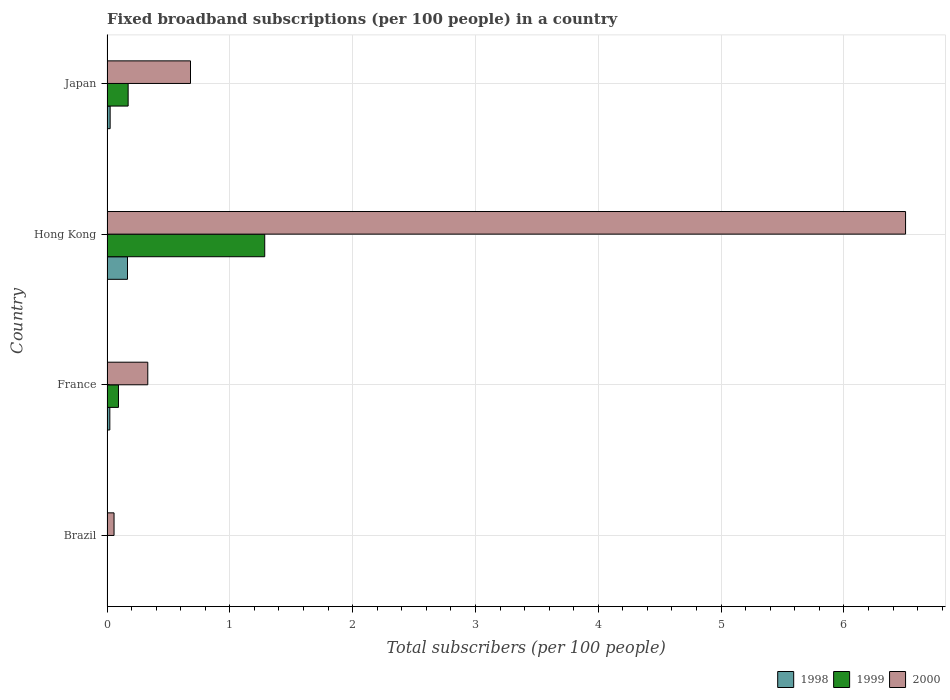How many groups of bars are there?
Make the answer very short. 4. Are the number of bars per tick equal to the number of legend labels?
Your answer should be very brief. Yes. What is the label of the 3rd group of bars from the top?
Make the answer very short. France. In how many cases, is the number of bars for a given country not equal to the number of legend labels?
Your response must be concise. 0. What is the number of broadband subscriptions in 2000 in Brazil?
Make the answer very short. 0.06. Across all countries, what is the maximum number of broadband subscriptions in 1998?
Offer a very short reply. 0.17. Across all countries, what is the minimum number of broadband subscriptions in 2000?
Make the answer very short. 0.06. In which country was the number of broadband subscriptions in 2000 maximum?
Offer a very short reply. Hong Kong. What is the total number of broadband subscriptions in 1999 in the graph?
Make the answer very short. 1.55. What is the difference between the number of broadband subscriptions in 1998 in Hong Kong and that in Japan?
Provide a succinct answer. 0.14. What is the difference between the number of broadband subscriptions in 1999 in Japan and the number of broadband subscriptions in 1998 in France?
Provide a succinct answer. 0.15. What is the average number of broadband subscriptions in 1998 per country?
Provide a short and direct response. 0.05. What is the difference between the number of broadband subscriptions in 1999 and number of broadband subscriptions in 1998 in France?
Make the answer very short. 0.07. What is the ratio of the number of broadband subscriptions in 2000 in France to that in Japan?
Provide a succinct answer. 0.49. Is the difference between the number of broadband subscriptions in 1999 in Hong Kong and Japan greater than the difference between the number of broadband subscriptions in 1998 in Hong Kong and Japan?
Offer a terse response. Yes. What is the difference between the highest and the second highest number of broadband subscriptions in 1999?
Your response must be concise. 1.11. What is the difference between the highest and the lowest number of broadband subscriptions in 2000?
Provide a short and direct response. 6.44. In how many countries, is the number of broadband subscriptions in 1999 greater than the average number of broadband subscriptions in 1999 taken over all countries?
Provide a succinct answer. 1. Is the sum of the number of broadband subscriptions in 1998 in Hong Kong and Japan greater than the maximum number of broadband subscriptions in 1999 across all countries?
Make the answer very short. No. Is it the case that in every country, the sum of the number of broadband subscriptions in 1999 and number of broadband subscriptions in 2000 is greater than the number of broadband subscriptions in 1998?
Provide a succinct answer. Yes. How many bars are there?
Give a very brief answer. 12. Are all the bars in the graph horizontal?
Your answer should be compact. Yes. How many countries are there in the graph?
Your answer should be compact. 4. What is the difference between two consecutive major ticks on the X-axis?
Your response must be concise. 1. Are the values on the major ticks of X-axis written in scientific E-notation?
Give a very brief answer. No. Where does the legend appear in the graph?
Your response must be concise. Bottom right. How many legend labels are there?
Keep it short and to the point. 3. How are the legend labels stacked?
Your answer should be compact. Horizontal. What is the title of the graph?
Offer a very short reply. Fixed broadband subscriptions (per 100 people) in a country. What is the label or title of the X-axis?
Your answer should be very brief. Total subscribers (per 100 people). What is the Total subscribers (per 100 people) in 1998 in Brazil?
Offer a terse response. 0. What is the Total subscribers (per 100 people) of 1999 in Brazil?
Give a very brief answer. 0. What is the Total subscribers (per 100 people) of 2000 in Brazil?
Ensure brevity in your answer.  0.06. What is the Total subscribers (per 100 people) of 1998 in France?
Offer a terse response. 0.02. What is the Total subscribers (per 100 people) of 1999 in France?
Provide a succinct answer. 0.09. What is the Total subscribers (per 100 people) in 2000 in France?
Your response must be concise. 0.33. What is the Total subscribers (per 100 people) of 1998 in Hong Kong?
Offer a very short reply. 0.17. What is the Total subscribers (per 100 people) of 1999 in Hong Kong?
Give a very brief answer. 1.28. What is the Total subscribers (per 100 people) of 2000 in Hong Kong?
Offer a very short reply. 6.5. What is the Total subscribers (per 100 people) in 1998 in Japan?
Offer a very short reply. 0.03. What is the Total subscribers (per 100 people) in 1999 in Japan?
Offer a terse response. 0.17. What is the Total subscribers (per 100 people) in 2000 in Japan?
Your response must be concise. 0.68. Across all countries, what is the maximum Total subscribers (per 100 people) in 1998?
Offer a very short reply. 0.17. Across all countries, what is the maximum Total subscribers (per 100 people) of 1999?
Your answer should be compact. 1.28. Across all countries, what is the maximum Total subscribers (per 100 people) of 2000?
Offer a very short reply. 6.5. Across all countries, what is the minimum Total subscribers (per 100 people) of 1998?
Provide a short and direct response. 0. Across all countries, what is the minimum Total subscribers (per 100 people) in 1999?
Make the answer very short. 0. Across all countries, what is the minimum Total subscribers (per 100 people) of 2000?
Your answer should be very brief. 0.06. What is the total Total subscribers (per 100 people) in 1998 in the graph?
Offer a terse response. 0.22. What is the total Total subscribers (per 100 people) of 1999 in the graph?
Keep it short and to the point. 1.55. What is the total Total subscribers (per 100 people) in 2000 in the graph?
Make the answer very short. 7.57. What is the difference between the Total subscribers (per 100 people) in 1998 in Brazil and that in France?
Provide a succinct answer. -0.02. What is the difference between the Total subscribers (per 100 people) of 1999 in Brazil and that in France?
Keep it short and to the point. -0.09. What is the difference between the Total subscribers (per 100 people) in 2000 in Brazil and that in France?
Provide a short and direct response. -0.27. What is the difference between the Total subscribers (per 100 people) of 1998 in Brazil and that in Hong Kong?
Your answer should be very brief. -0.17. What is the difference between the Total subscribers (per 100 people) of 1999 in Brazil and that in Hong Kong?
Ensure brevity in your answer.  -1.28. What is the difference between the Total subscribers (per 100 people) in 2000 in Brazil and that in Hong Kong?
Offer a very short reply. -6.45. What is the difference between the Total subscribers (per 100 people) of 1998 in Brazil and that in Japan?
Your answer should be very brief. -0.03. What is the difference between the Total subscribers (per 100 people) of 1999 in Brazil and that in Japan?
Offer a very short reply. -0.17. What is the difference between the Total subscribers (per 100 people) in 2000 in Brazil and that in Japan?
Give a very brief answer. -0.62. What is the difference between the Total subscribers (per 100 people) of 1998 in France and that in Hong Kong?
Give a very brief answer. -0.14. What is the difference between the Total subscribers (per 100 people) of 1999 in France and that in Hong Kong?
Make the answer very short. -1.19. What is the difference between the Total subscribers (per 100 people) of 2000 in France and that in Hong Kong?
Your answer should be compact. -6.17. What is the difference between the Total subscribers (per 100 people) in 1998 in France and that in Japan?
Ensure brevity in your answer.  -0. What is the difference between the Total subscribers (per 100 people) in 1999 in France and that in Japan?
Provide a succinct answer. -0.08. What is the difference between the Total subscribers (per 100 people) of 2000 in France and that in Japan?
Your response must be concise. -0.35. What is the difference between the Total subscribers (per 100 people) of 1998 in Hong Kong and that in Japan?
Offer a very short reply. 0.14. What is the difference between the Total subscribers (per 100 people) of 1999 in Hong Kong and that in Japan?
Offer a very short reply. 1.11. What is the difference between the Total subscribers (per 100 people) in 2000 in Hong Kong and that in Japan?
Offer a very short reply. 5.82. What is the difference between the Total subscribers (per 100 people) in 1998 in Brazil and the Total subscribers (per 100 people) in 1999 in France?
Ensure brevity in your answer.  -0.09. What is the difference between the Total subscribers (per 100 people) in 1998 in Brazil and the Total subscribers (per 100 people) in 2000 in France?
Provide a short and direct response. -0.33. What is the difference between the Total subscribers (per 100 people) in 1999 in Brazil and the Total subscribers (per 100 people) in 2000 in France?
Make the answer very short. -0.33. What is the difference between the Total subscribers (per 100 people) in 1998 in Brazil and the Total subscribers (per 100 people) in 1999 in Hong Kong?
Your answer should be compact. -1.28. What is the difference between the Total subscribers (per 100 people) of 1998 in Brazil and the Total subscribers (per 100 people) of 2000 in Hong Kong?
Provide a succinct answer. -6.5. What is the difference between the Total subscribers (per 100 people) of 1999 in Brazil and the Total subscribers (per 100 people) of 2000 in Hong Kong?
Offer a very short reply. -6.5. What is the difference between the Total subscribers (per 100 people) in 1998 in Brazil and the Total subscribers (per 100 people) in 1999 in Japan?
Your response must be concise. -0.17. What is the difference between the Total subscribers (per 100 people) of 1998 in Brazil and the Total subscribers (per 100 people) of 2000 in Japan?
Ensure brevity in your answer.  -0.68. What is the difference between the Total subscribers (per 100 people) of 1999 in Brazil and the Total subscribers (per 100 people) of 2000 in Japan?
Your response must be concise. -0.68. What is the difference between the Total subscribers (per 100 people) in 1998 in France and the Total subscribers (per 100 people) in 1999 in Hong Kong?
Make the answer very short. -1.26. What is the difference between the Total subscribers (per 100 people) of 1998 in France and the Total subscribers (per 100 people) of 2000 in Hong Kong?
Provide a short and direct response. -6.48. What is the difference between the Total subscribers (per 100 people) in 1999 in France and the Total subscribers (per 100 people) in 2000 in Hong Kong?
Your response must be concise. -6.41. What is the difference between the Total subscribers (per 100 people) in 1998 in France and the Total subscribers (per 100 people) in 1999 in Japan?
Provide a short and direct response. -0.15. What is the difference between the Total subscribers (per 100 people) in 1998 in France and the Total subscribers (per 100 people) in 2000 in Japan?
Offer a terse response. -0.66. What is the difference between the Total subscribers (per 100 people) of 1999 in France and the Total subscribers (per 100 people) of 2000 in Japan?
Provide a short and direct response. -0.59. What is the difference between the Total subscribers (per 100 people) of 1998 in Hong Kong and the Total subscribers (per 100 people) of 1999 in Japan?
Offer a very short reply. -0.01. What is the difference between the Total subscribers (per 100 people) of 1998 in Hong Kong and the Total subscribers (per 100 people) of 2000 in Japan?
Ensure brevity in your answer.  -0.51. What is the difference between the Total subscribers (per 100 people) of 1999 in Hong Kong and the Total subscribers (per 100 people) of 2000 in Japan?
Make the answer very short. 0.6. What is the average Total subscribers (per 100 people) in 1998 per country?
Provide a succinct answer. 0.05. What is the average Total subscribers (per 100 people) of 1999 per country?
Ensure brevity in your answer.  0.39. What is the average Total subscribers (per 100 people) of 2000 per country?
Your response must be concise. 1.89. What is the difference between the Total subscribers (per 100 people) in 1998 and Total subscribers (per 100 people) in 1999 in Brazil?
Your answer should be compact. -0. What is the difference between the Total subscribers (per 100 people) in 1998 and Total subscribers (per 100 people) in 2000 in Brazil?
Your response must be concise. -0.06. What is the difference between the Total subscribers (per 100 people) in 1999 and Total subscribers (per 100 people) in 2000 in Brazil?
Offer a very short reply. -0.05. What is the difference between the Total subscribers (per 100 people) in 1998 and Total subscribers (per 100 people) in 1999 in France?
Offer a terse response. -0.07. What is the difference between the Total subscribers (per 100 people) in 1998 and Total subscribers (per 100 people) in 2000 in France?
Provide a succinct answer. -0.31. What is the difference between the Total subscribers (per 100 people) of 1999 and Total subscribers (per 100 people) of 2000 in France?
Offer a very short reply. -0.24. What is the difference between the Total subscribers (per 100 people) in 1998 and Total subscribers (per 100 people) in 1999 in Hong Kong?
Keep it short and to the point. -1.12. What is the difference between the Total subscribers (per 100 people) in 1998 and Total subscribers (per 100 people) in 2000 in Hong Kong?
Ensure brevity in your answer.  -6.34. What is the difference between the Total subscribers (per 100 people) in 1999 and Total subscribers (per 100 people) in 2000 in Hong Kong?
Give a very brief answer. -5.22. What is the difference between the Total subscribers (per 100 people) of 1998 and Total subscribers (per 100 people) of 1999 in Japan?
Provide a short and direct response. -0.15. What is the difference between the Total subscribers (per 100 people) in 1998 and Total subscribers (per 100 people) in 2000 in Japan?
Offer a terse response. -0.65. What is the difference between the Total subscribers (per 100 people) in 1999 and Total subscribers (per 100 people) in 2000 in Japan?
Give a very brief answer. -0.51. What is the ratio of the Total subscribers (per 100 people) in 1998 in Brazil to that in France?
Provide a short and direct response. 0.03. What is the ratio of the Total subscribers (per 100 people) of 1999 in Brazil to that in France?
Give a very brief answer. 0.04. What is the ratio of the Total subscribers (per 100 people) in 2000 in Brazil to that in France?
Keep it short and to the point. 0.17. What is the ratio of the Total subscribers (per 100 people) of 1998 in Brazil to that in Hong Kong?
Provide a succinct answer. 0. What is the ratio of the Total subscribers (per 100 people) in 1999 in Brazil to that in Hong Kong?
Your answer should be very brief. 0. What is the ratio of the Total subscribers (per 100 people) in 2000 in Brazil to that in Hong Kong?
Ensure brevity in your answer.  0.01. What is the ratio of the Total subscribers (per 100 people) of 1998 in Brazil to that in Japan?
Make the answer very short. 0.02. What is the ratio of the Total subscribers (per 100 people) in 1999 in Brazil to that in Japan?
Your response must be concise. 0.02. What is the ratio of the Total subscribers (per 100 people) in 2000 in Brazil to that in Japan?
Keep it short and to the point. 0.08. What is the ratio of the Total subscribers (per 100 people) in 1998 in France to that in Hong Kong?
Ensure brevity in your answer.  0.14. What is the ratio of the Total subscribers (per 100 people) of 1999 in France to that in Hong Kong?
Offer a terse response. 0.07. What is the ratio of the Total subscribers (per 100 people) of 2000 in France to that in Hong Kong?
Offer a terse response. 0.05. What is the ratio of the Total subscribers (per 100 people) of 1998 in France to that in Japan?
Offer a very short reply. 0.9. What is the ratio of the Total subscribers (per 100 people) in 1999 in France to that in Japan?
Offer a very short reply. 0.54. What is the ratio of the Total subscribers (per 100 people) in 2000 in France to that in Japan?
Make the answer very short. 0.49. What is the ratio of the Total subscribers (per 100 people) in 1998 in Hong Kong to that in Japan?
Your answer should be very brief. 6.53. What is the ratio of the Total subscribers (per 100 people) in 1999 in Hong Kong to that in Japan?
Provide a succinct answer. 7.46. What is the ratio of the Total subscribers (per 100 people) of 2000 in Hong Kong to that in Japan?
Offer a terse response. 9.56. What is the difference between the highest and the second highest Total subscribers (per 100 people) in 1998?
Your response must be concise. 0.14. What is the difference between the highest and the second highest Total subscribers (per 100 people) in 1999?
Keep it short and to the point. 1.11. What is the difference between the highest and the second highest Total subscribers (per 100 people) in 2000?
Provide a succinct answer. 5.82. What is the difference between the highest and the lowest Total subscribers (per 100 people) in 1998?
Offer a terse response. 0.17. What is the difference between the highest and the lowest Total subscribers (per 100 people) of 1999?
Keep it short and to the point. 1.28. What is the difference between the highest and the lowest Total subscribers (per 100 people) of 2000?
Your answer should be very brief. 6.45. 